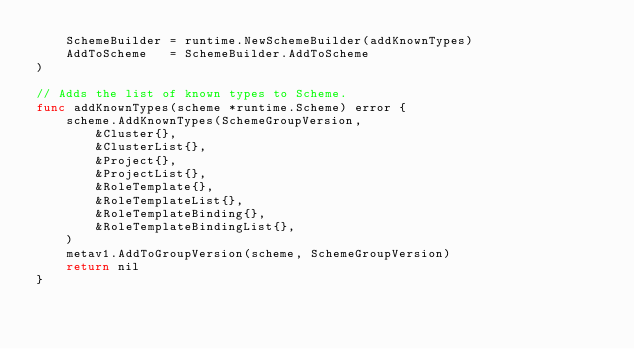Convert code to text. <code><loc_0><loc_0><loc_500><loc_500><_Go_>	SchemeBuilder = runtime.NewSchemeBuilder(addKnownTypes)
	AddToScheme   = SchemeBuilder.AddToScheme
)

// Adds the list of known types to Scheme.
func addKnownTypes(scheme *runtime.Scheme) error {
	scheme.AddKnownTypes(SchemeGroupVersion,
		&Cluster{},
		&ClusterList{},
		&Project{},
		&ProjectList{},
		&RoleTemplate{},
		&RoleTemplateList{},
		&RoleTemplateBinding{},
		&RoleTemplateBindingList{},
	)
	metav1.AddToGroupVersion(scheme, SchemeGroupVersion)
	return nil
}
</code> 